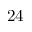<formula> <loc_0><loc_0><loc_500><loc_500>2 4</formula> 